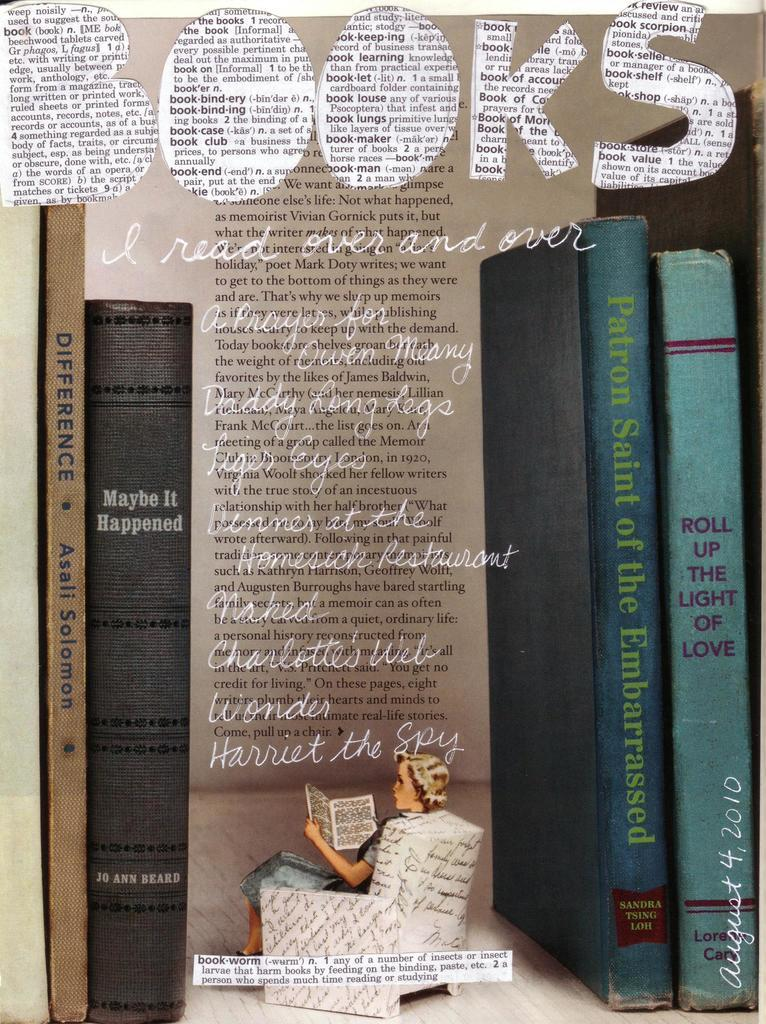Provide a one-sentence caption for the provided image. An advertisement for books with a woman reading a book on the front. 